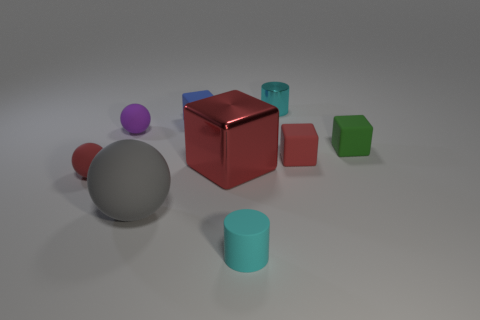There is a red object right of the tiny metallic cylinder that is behind the tiny green rubber object; how many cylinders are in front of it?
Make the answer very short. 1. Does the tiny red rubber thing on the left side of the cyan matte cylinder have the same shape as the purple object?
Offer a very short reply. Yes. There is a small object in front of the large gray rubber sphere; what material is it?
Your answer should be very brief. Rubber. There is a tiny rubber thing that is in front of the large red shiny object and right of the large rubber ball; what is its shape?
Provide a succinct answer. Cylinder. What material is the small blue block?
Give a very brief answer. Rubber. What number of blocks are tiny red objects or big matte objects?
Offer a very short reply. 1. Do the tiny blue thing and the gray thing have the same material?
Keep it short and to the point. Yes. There is another cyan thing that is the same shape as the cyan rubber thing; what is its size?
Provide a succinct answer. Small. There is a object that is both right of the large red block and in front of the red matte ball; what is its material?
Make the answer very short. Rubber. Are there the same number of small cylinders behind the tiny blue object and big cyan shiny things?
Ensure brevity in your answer.  No. 